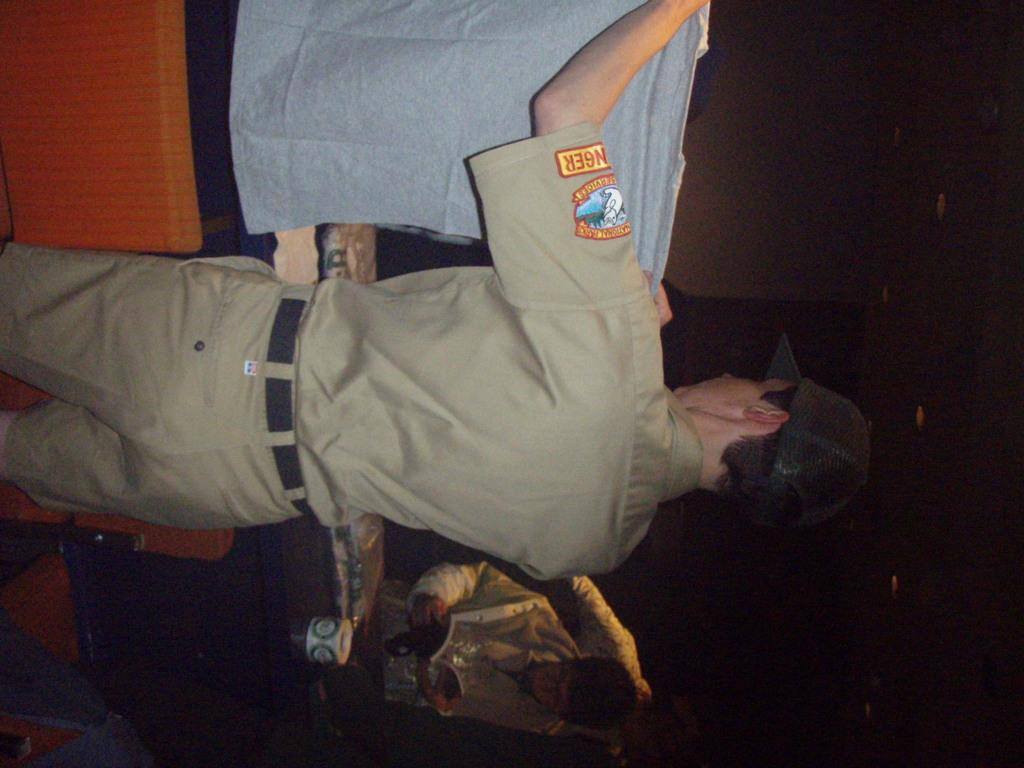What is the main subject in the foreground of the image? There is a cop in the foreground of the image. What is the cop holding in the image? The cop is holding a T-shirt. Who else is present in the image? There is a boy in the image. What is the boy holding in the image? The boy is holding a book and a mug. What is the setting of the image? The setting appears to be a desk. What is visible in the background area? There is a lamp in the background area. What is the name of the bird that is sitting on the boy's shoulder in the image? There is no bird present in the image, so it is not possible to determine the name of a bird on the boy's shoulder. 